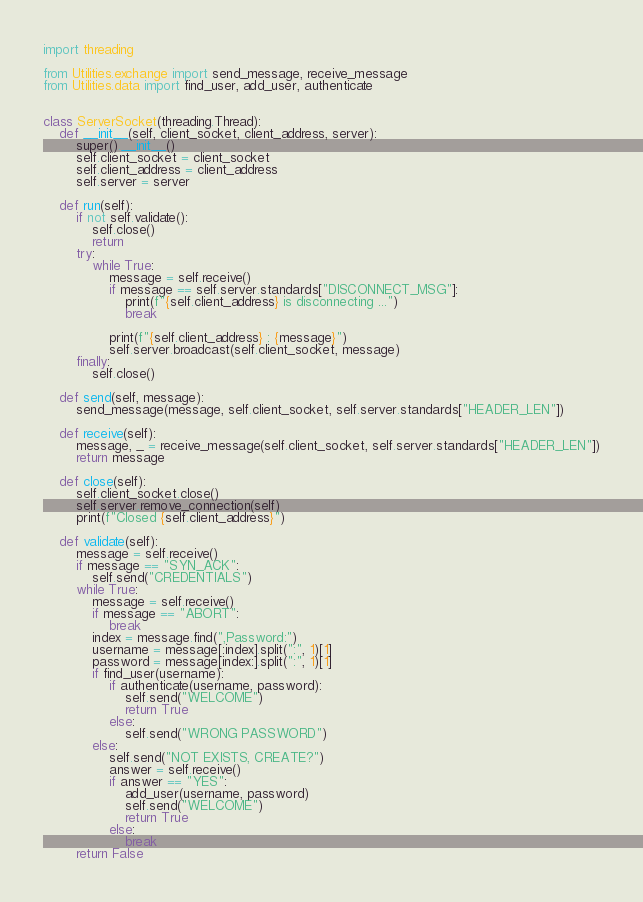<code> <loc_0><loc_0><loc_500><loc_500><_Python_>import threading

from Utilities.exchange import send_message, receive_message
from Utilities.data import find_user, add_user, authenticate


class ServerSocket(threading.Thread):
    def __init__(self, client_socket, client_address, server):
        super().__init__()
        self.client_socket = client_socket
        self.client_address = client_address
        self.server = server

    def run(self):
        if not self.validate():
            self.close()
            return
        try:
            while True:
                message = self.receive()
                if message == self.server.standards["DISCONNECT_MSG"]:
                    print(f"{self.client_address} is disconnecting ...")
                    break

                print(f"{self.client_address} : {message}")
                self.server.broadcast(self.client_socket, message)
        finally:
            self.close()

    def send(self, message):
        send_message(message, self.client_socket, self.server.standards["HEADER_LEN"])

    def receive(self):
        message, _ = receive_message(self.client_socket, self.server.standards["HEADER_LEN"])
        return message

    def close(self):
        self.client_socket.close()
        self.server.remove_connection(self)
        print(f"Closed {self.client_address}")

    def validate(self):
        message = self.receive()
        if message == "SYN_ACK":
            self.send("CREDENTIALS")
        while True:
            message = self.receive()
            if message == "ABORT":
                break
            index = message.find(",Password:")
            username = message[:index].split(":", 1)[1]
            password = message[index:].split(":", 1)[1]
            if find_user(username):
                if authenticate(username, password):
                    self.send("WELCOME")
                    return True
                else:
                    self.send("WRONG PASSWORD")
            else:
                self.send("NOT EXISTS, CREATE?")
                answer = self.receive()
                if answer == "YES":
                    add_user(username, password)
                    self.send("WELCOME")
                    return True
                else:
                    break
        return False
</code> 